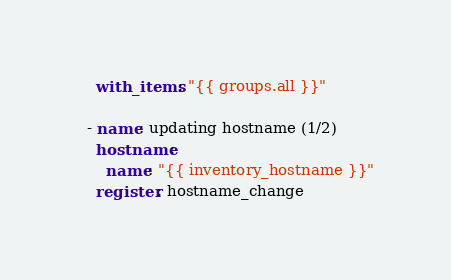<code> <loc_0><loc_0><loc_500><loc_500><_YAML_>    with_items: "{{ groups.all }}"

  - name: updating hostname (1/2)
    hostname:
      name: "{{ inventory_hostname }}"
    register: hostname_change
</code> 